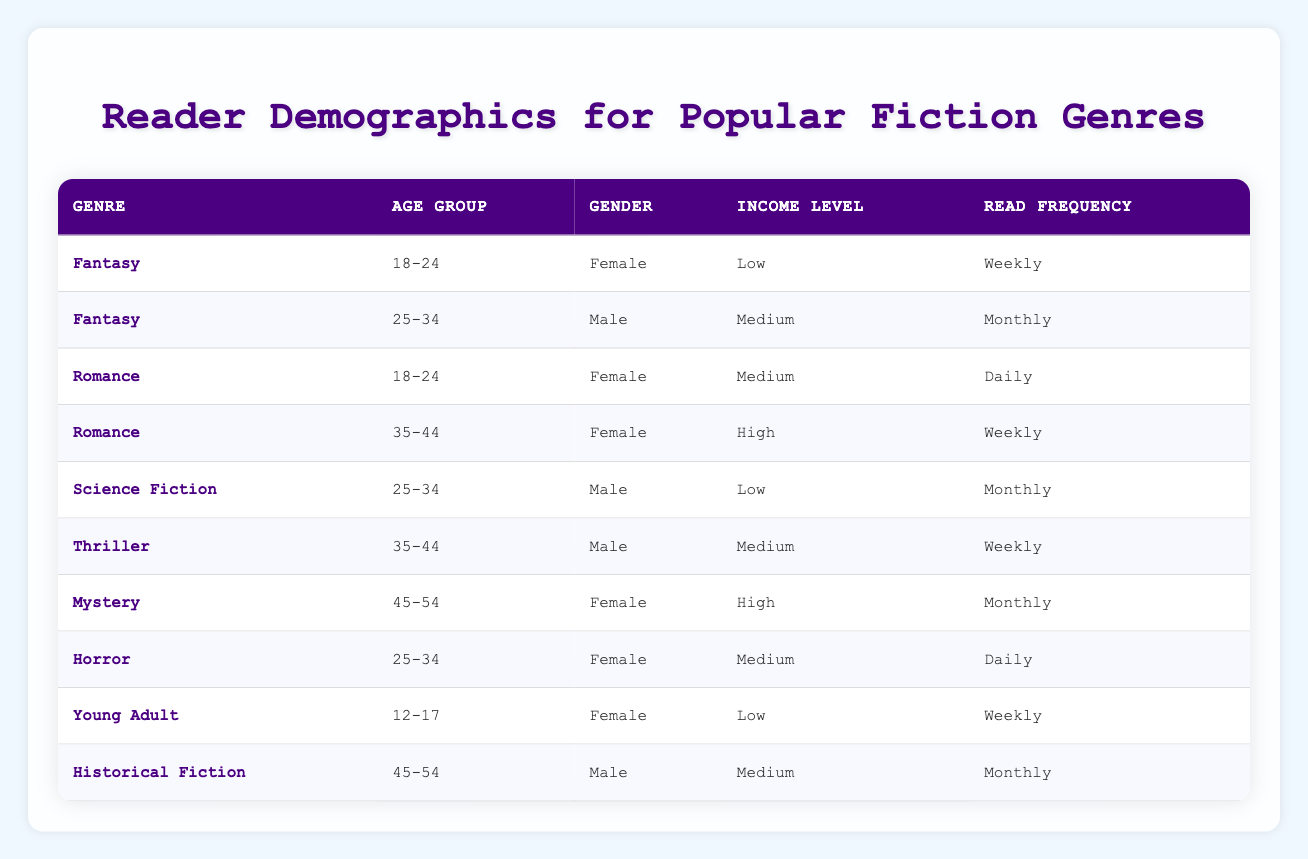What is the most common read frequency for the Fantasy genre? In the table, the Fantasy genre has two readers listed: one reads weekly and the other monthly. Since "Weekly" appears more frequently than "Monthly," it is the most common read frequency for this genre.
Answer: Weekly Which gender has the highest representation among readers of the Romance genre? The data for the Romance genre shows two entries, both of which are Female readers (ages 18-24 and 35-44). Since there are no male readers in this genre, Female is the only gender represented.
Answer: Female How many unique age groups are present across all genres? By scanning the age groups listed in the table: 12-17, 18-24, 25-34, 35-44, and 45-54, we find there are 5 unique age groups present in total.
Answer: 5 Is there a Horror reader in the age group of 18-24? The table shows no entries for Horror in the 18-24 age group; the only reader for Horror is a Female aged 25-34. Therefore, the statement is false.
Answer: No What percentage of Male readers prefers reading on a Monthly basis? There are a total of 4 Male readers: 25-34 (Fantasy), 25-34 (Science Fiction), 35-44 (Thriller), and 45-54 (Historical Fiction). Among these, 2 read Monthly (Fantasy and Historical Fiction). Therefore, the percentage is (2/4) * 100 = 50%.
Answer: 50% Which genre has the highest income level representation? The genres represented in the table along with their income levels are: Fantasy (Low, Medium), Romance (Medium, High), Science Fiction (Low), Thriller (Medium), Mystery (High), Horror (Medium), Young Adult (Low), Historical Fiction (Medium). Romance and Mystery have the highest income level represented, which is High.
Answer: Romance and Mystery What is the read frequency for the youngest age group (12-17) in the table? Looking at the entries, the only reader listed in the 12-17 age group is a Female reader of Young Adult who reads Weekly. So, the answer is Weekly.
Answer: Weekly How many genres do Female readers prefer reading on a Daily basis? Female readers read Daily in two genres: Romance (18-24) and Horror (25-34). Therefore, there are 2 genres where Female readers prefer this reading frequency.
Answer: 2 Which income level is most common among the 35-44 age group? The 35-44 age group has three readers: Romance (High), Thriller (Medium), and none for other genres mentioned. The highest representation in terms of income levels includes 1 High and 1 Medium. Since High is represented only once and Medium also once, there is no definitive most common due to equal representation.
Answer: Neither 